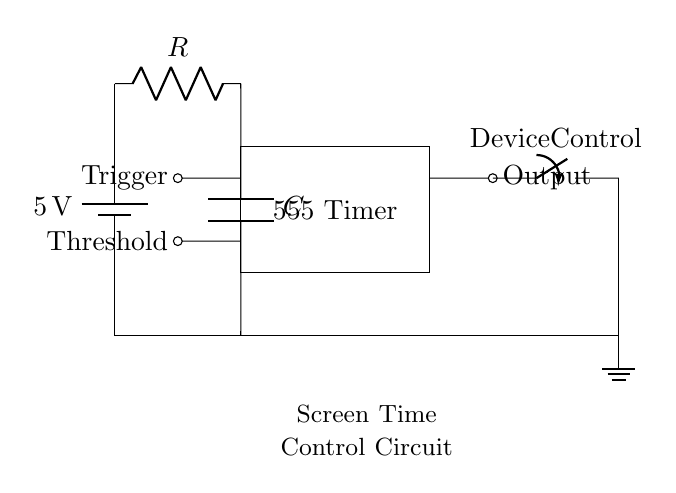What type of circuit is this? This circuit is a timer circuit, specifically using a 555 timer IC to control the electronic device's usage based on time.
Answer: Timer circuit What is the voltage of the power supply? The power supply voltage is specified at 5 volts, as indicated in the circuit diagram.
Answer: 5 volts What component triggers the timer? The Trigger pin on the 555 timer IC initiates the timing function in the circuit.
Answer: Trigger pin What is the purpose of the resistor and capacitor in this circuit? The resistor and capacitor together determine the time duration for which the timer operates, essentially setting the limits for device control.
Answer: Set timing What is connected to the output of the 555 timer? The device control switch is connected to the output of the 555 timer, allowing control of the device's operation based on the timer settings.
Answer: Device control switch How many components are in the timer circuit? There are three primary electronic components: the 555 timer IC, a resistor, and a capacitor, plus additional elements like the power supply and switch.
Answer: Three components What happens when the timer reaches its set time? When the timer reaches its set time, it will send a signal to the device control switch to either turn ON or OFF the connected device, effectively managing screen time.
Answer: Control device state 